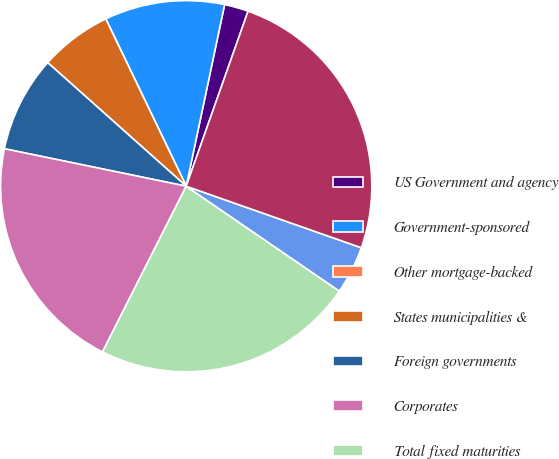Convert chart. <chart><loc_0><loc_0><loc_500><loc_500><pie_chart><fcel>US Government and agency<fcel>Government-sponsored<fcel>Other mortgage-backed<fcel>States municipalities &<fcel>Foreign governments<fcel>Corporates<fcel>Total fixed maturities<fcel>Equities<fcel>Total<nl><fcel>2.09%<fcel>10.45%<fcel>0.0%<fcel>6.27%<fcel>8.36%<fcel>20.79%<fcel>22.88%<fcel>4.18%<fcel>24.97%<nl></chart> 